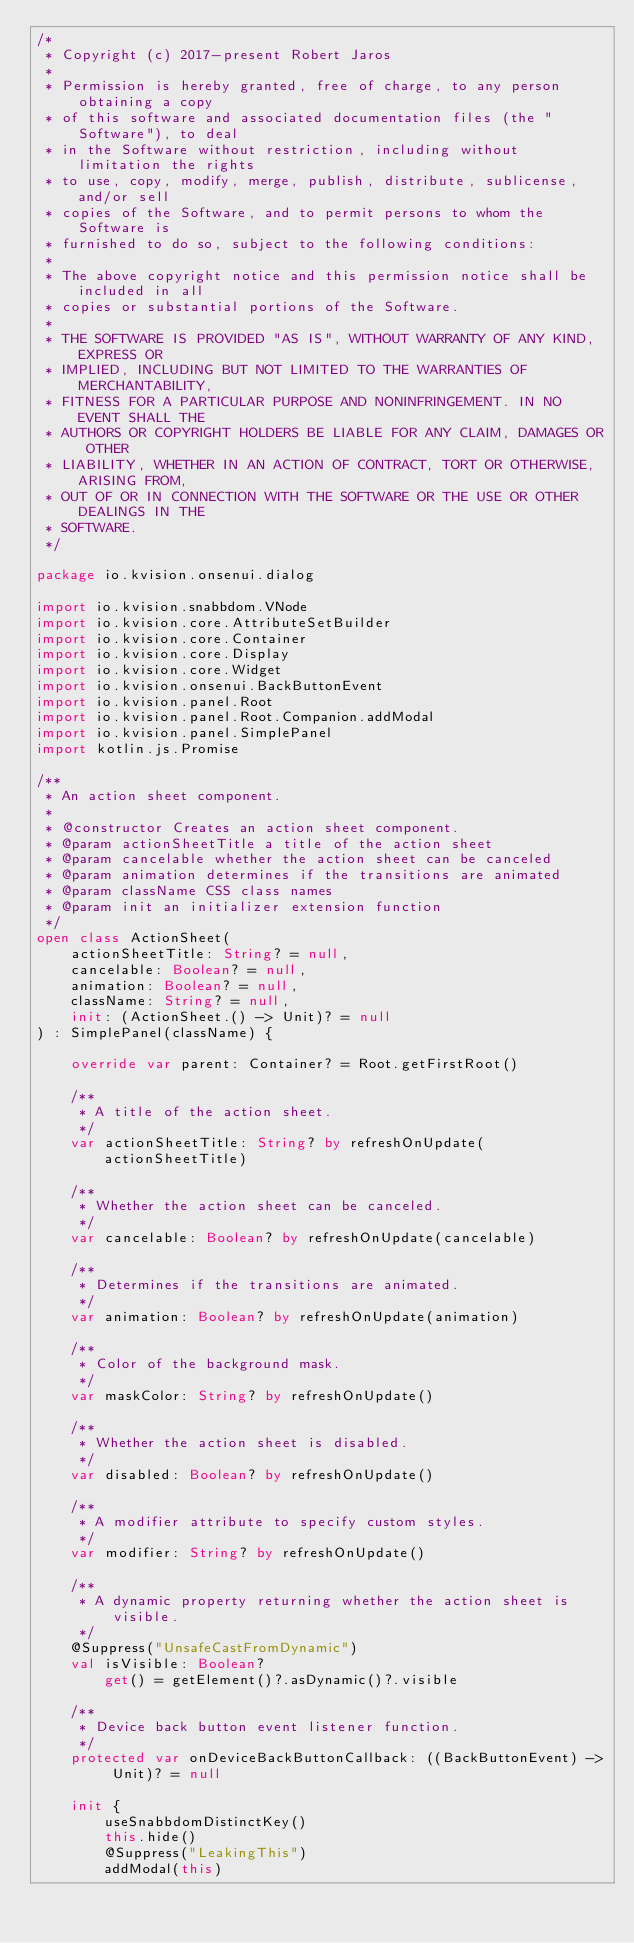Convert code to text. <code><loc_0><loc_0><loc_500><loc_500><_Kotlin_>/*
 * Copyright (c) 2017-present Robert Jaros
 *
 * Permission is hereby granted, free of charge, to any person obtaining a copy
 * of this software and associated documentation files (the "Software"), to deal
 * in the Software without restriction, including without limitation the rights
 * to use, copy, modify, merge, publish, distribute, sublicense, and/or sell
 * copies of the Software, and to permit persons to whom the Software is
 * furnished to do so, subject to the following conditions:
 *
 * The above copyright notice and this permission notice shall be included in all
 * copies or substantial portions of the Software.
 *
 * THE SOFTWARE IS PROVIDED "AS IS", WITHOUT WARRANTY OF ANY KIND, EXPRESS OR
 * IMPLIED, INCLUDING BUT NOT LIMITED TO THE WARRANTIES OF MERCHANTABILITY,
 * FITNESS FOR A PARTICULAR PURPOSE AND NONINFRINGEMENT. IN NO EVENT SHALL THE
 * AUTHORS OR COPYRIGHT HOLDERS BE LIABLE FOR ANY CLAIM, DAMAGES OR OTHER
 * LIABILITY, WHETHER IN AN ACTION OF CONTRACT, TORT OR OTHERWISE, ARISING FROM,
 * OUT OF OR IN CONNECTION WITH THE SOFTWARE OR THE USE OR OTHER DEALINGS IN THE
 * SOFTWARE.
 */

package io.kvision.onsenui.dialog

import io.kvision.snabbdom.VNode
import io.kvision.core.AttributeSetBuilder
import io.kvision.core.Container
import io.kvision.core.Display
import io.kvision.core.Widget
import io.kvision.onsenui.BackButtonEvent
import io.kvision.panel.Root
import io.kvision.panel.Root.Companion.addModal
import io.kvision.panel.SimplePanel
import kotlin.js.Promise

/**
 * An action sheet component.
 *
 * @constructor Creates an action sheet component.
 * @param actionSheetTitle a title of the action sheet
 * @param cancelable whether the action sheet can be canceled
 * @param animation determines if the transitions are animated
 * @param className CSS class names
 * @param init an initializer extension function
 */
open class ActionSheet(
    actionSheetTitle: String? = null,
    cancelable: Boolean? = null,
    animation: Boolean? = null,
    className: String? = null,
    init: (ActionSheet.() -> Unit)? = null
) : SimplePanel(className) {

    override var parent: Container? = Root.getFirstRoot()

    /**
     * A title of the action sheet.
     */
    var actionSheetTitle: String? by refreshOnUpdate(actionSheetTitle)

    /**
     * Whether the action sheet can be canceled.
     */
    var cancelable: Boolean? by refreshOnUpdate(cancelable)

    /**
     * Determines if the transitions are animated.
     */
    var animation: Boolean? by refreshOnUpdate(animation)

    /**
     * Color of the background mask.
     */
    var maskColor: String? by refreshOnUpdate()

    /**
     * Whether the action sheet is disabled.
     */
    var disabled: Boolean? by refreshOnUpdate()

    /**
     * A modifier attribute to specify custom styles.
     */
    var modifier: String? by refreshOnUpdate()

    /**
     * A dynamic property returning whether the action sheet is visible.
     */
    @Suppress("UnsafeCastFromDynamic")
    val isVisible: Boolean?
        get() = getElement()?.asDynamic()?.visible

    /**
     * Device back button event listener function.
     */
    protected var onDeviceBackButtonCallback: ((BackButtonEvent) -> Unit)? = null

    init {
        useSnabbdomDistinctKey()
        this.hide()
        @Suppress("LeakingThis")
        addModal(this)</code> 